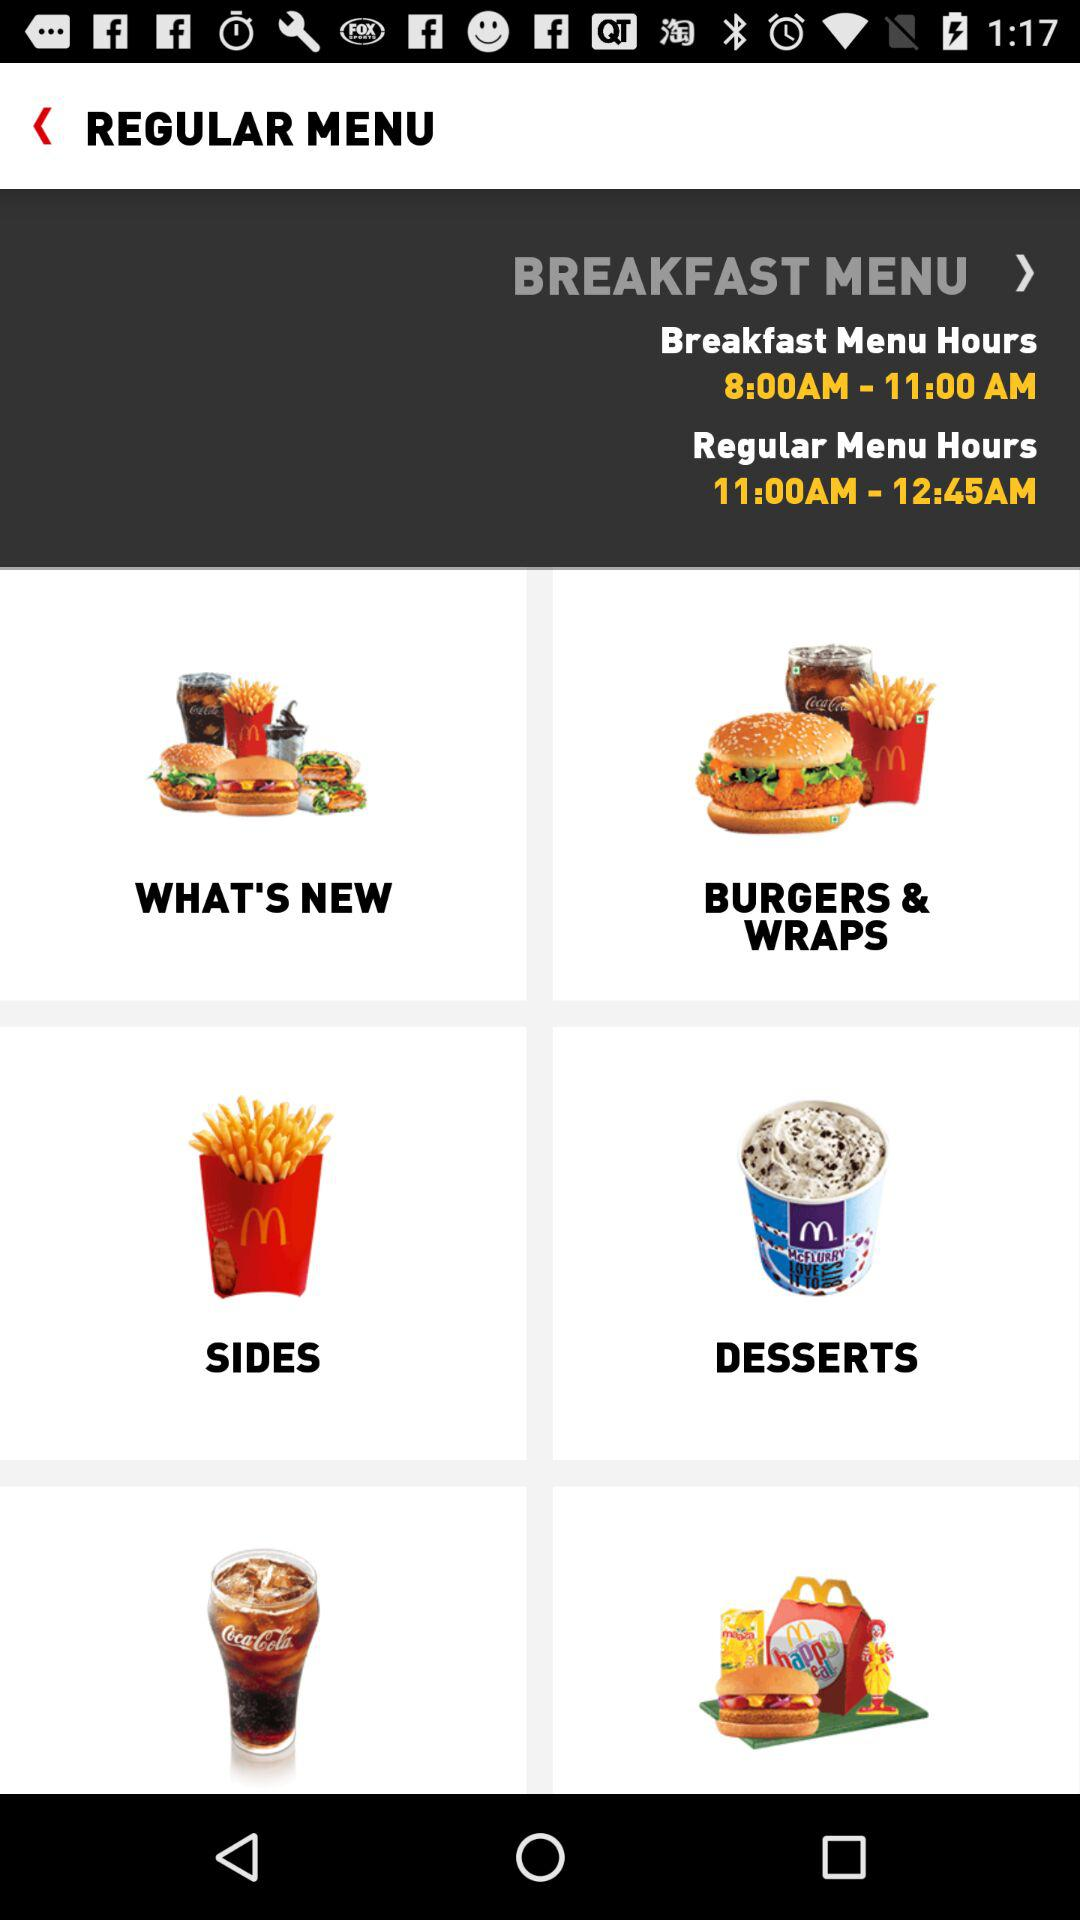What are the timings given for the breakfast menu hours? The timings for the breakfast are from 8:00 a.m. to 11:00 a.m. 